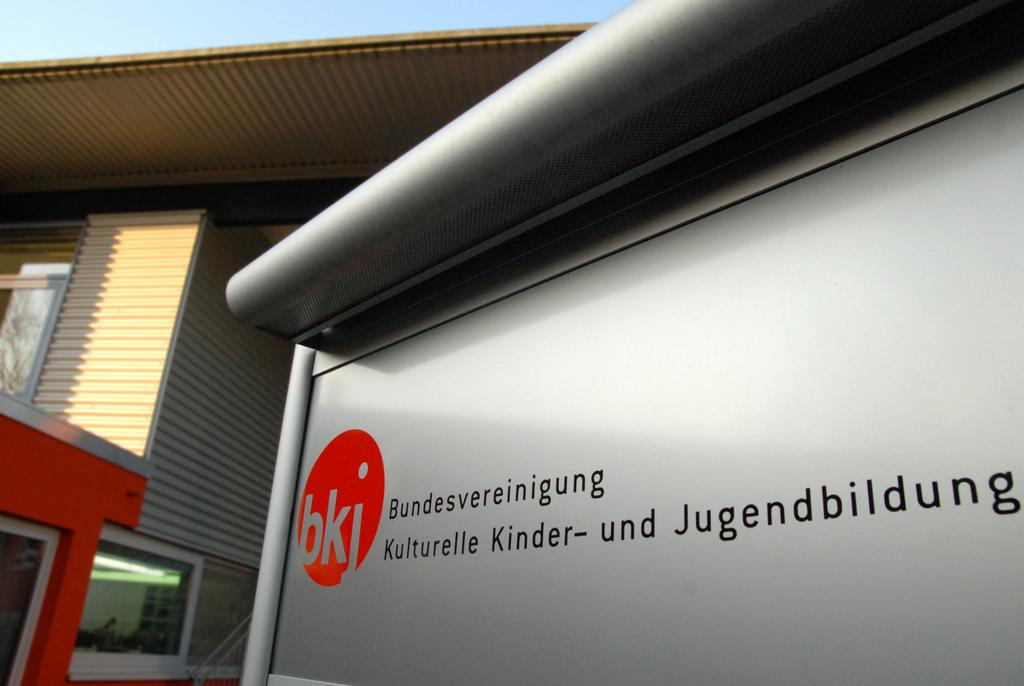What is the main subject in the center of the image? There is a name board in the center of the image. What can be seen in the background of the image? There is a building and the sky visible in the background of the image. What type of music is the band playing in the background of the image? There is no band present in the image, so it is not possible to determine what type of music might be playing. 